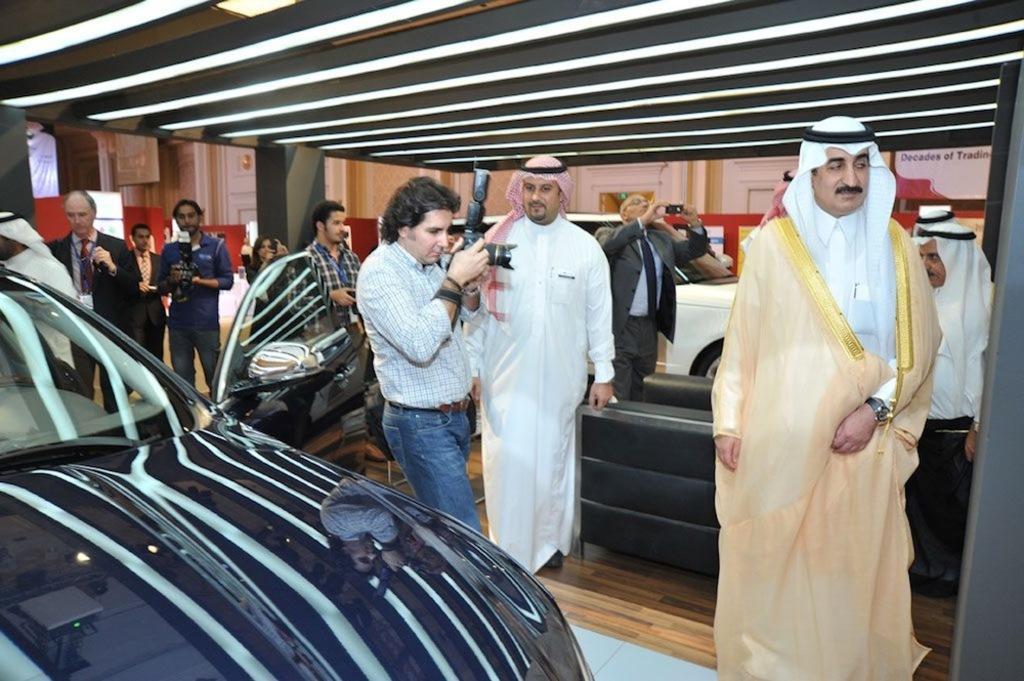How would you summarize this image in a sentence or two? In the foreground of the image there is a car. There are people standing. At the top of the image there is ceiling. In the background of the image there is wall. There are cars. At the bottom of the image there is wooden flooring. 